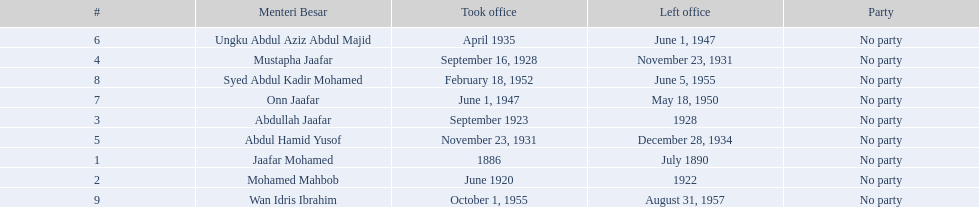Who were all of the menteri besars? Jaafar Mohamed, Mohamed Mahbob, Abdullah Jaafar, Mustapha Jaafar, Abdul Hamid Yusof, Ungku Abdul Aziz Abdul Majid, Onn Jaafar, Syed Abdul Kadir Mohamed, Wan Idris Ibrahim. When did they take office? 1886, June 1920, September 1923, September 16, 1928, November 23, 1931, April 1935, June 1, 1947, February 18, 1952, October 1, 1955. And when did they leave? July 1890, 1922, 1928, November 23, 1931, December 28, 1934, June 1, 1947, May 18, 1950, June 5, 1955, August 31, 1957. Now, who was in office for less than four years? Mohamed Mahbob. 